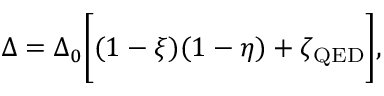<formula> <loc_0><loc_0><loc_500><loc_500>\Delta = \Delta _ { 0 } \left [ ( 1 - \xi ) ( 1 - \eta ) + \zeta _ { Q E D } \right ] ,</formula> 